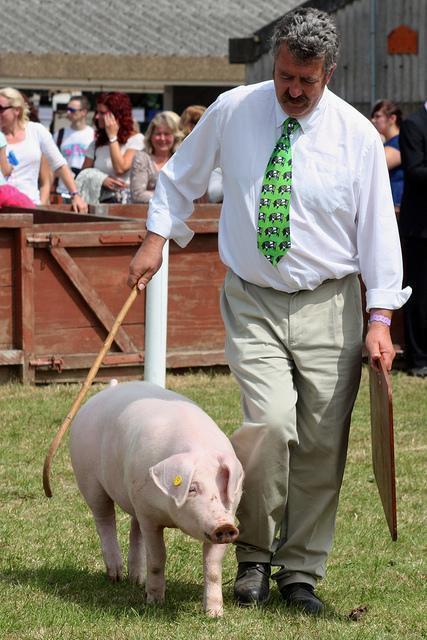What is the pig here entered in?
Select the accurate answer and provide explanation: 'Answer: answer
Rationale: rationale.'
Options: Show, race, roping contest, beauty contest. Answer: show.
Rationale: The man is showing how well he can control the pig. there are spectators watching. 